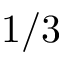Convert formula to latex. <formula><loc_0><loc_0><loc_500><loc_500>1 / 3</formula> 